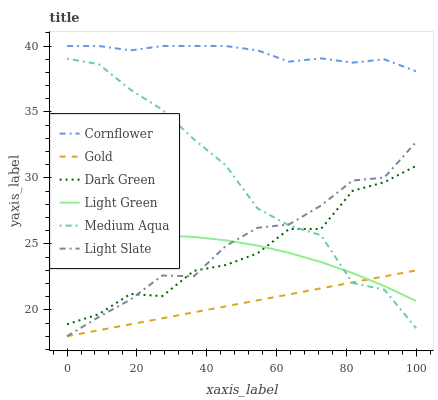Does Gold have the minimum area under the curve?
Answer yes or no. Yes. Does Cornflower have the maximum area under the curve?
Answer yes or no. Yes. Does Light Slate have the minimum area under the curve?
Answer yes or no. No. Does Light Slate have the maximum area under the curve?
Answer yes or no. No. Is Gold the smoothest?
Answer yes or no. Yes. Is Medium Aqua the roughest?
Answer yes or no. Yes. Is Light Slate the smoothest?
Answer yes or no. No. Is Light Slate the roughest?
Answer yes or no. No. Does Gold have the lowest value?
Answer yes or no. Yes. Does Medium Aqua have the lowest value?
Answer yes or no. No. Does Cornflower have the highest value?
Answer yes or no. Yes. Does Light Slate have the highest value?
Answer yes or no. No. Is Gold less than Dark Green?
Answer yes or no. Yes. Is Dark Green greater than Gold?
Answer yes or no. Yes. Does Gold intersect Medium Aqua?
Answer yes or no. Yes. Is Gold less than Medium Aqua?
Answer yes or no. No. Is Gold greater than Medium Aqua?
Answer yes or no. No. Does Gold intersect Dark Green?
Answer yes or no. No. 